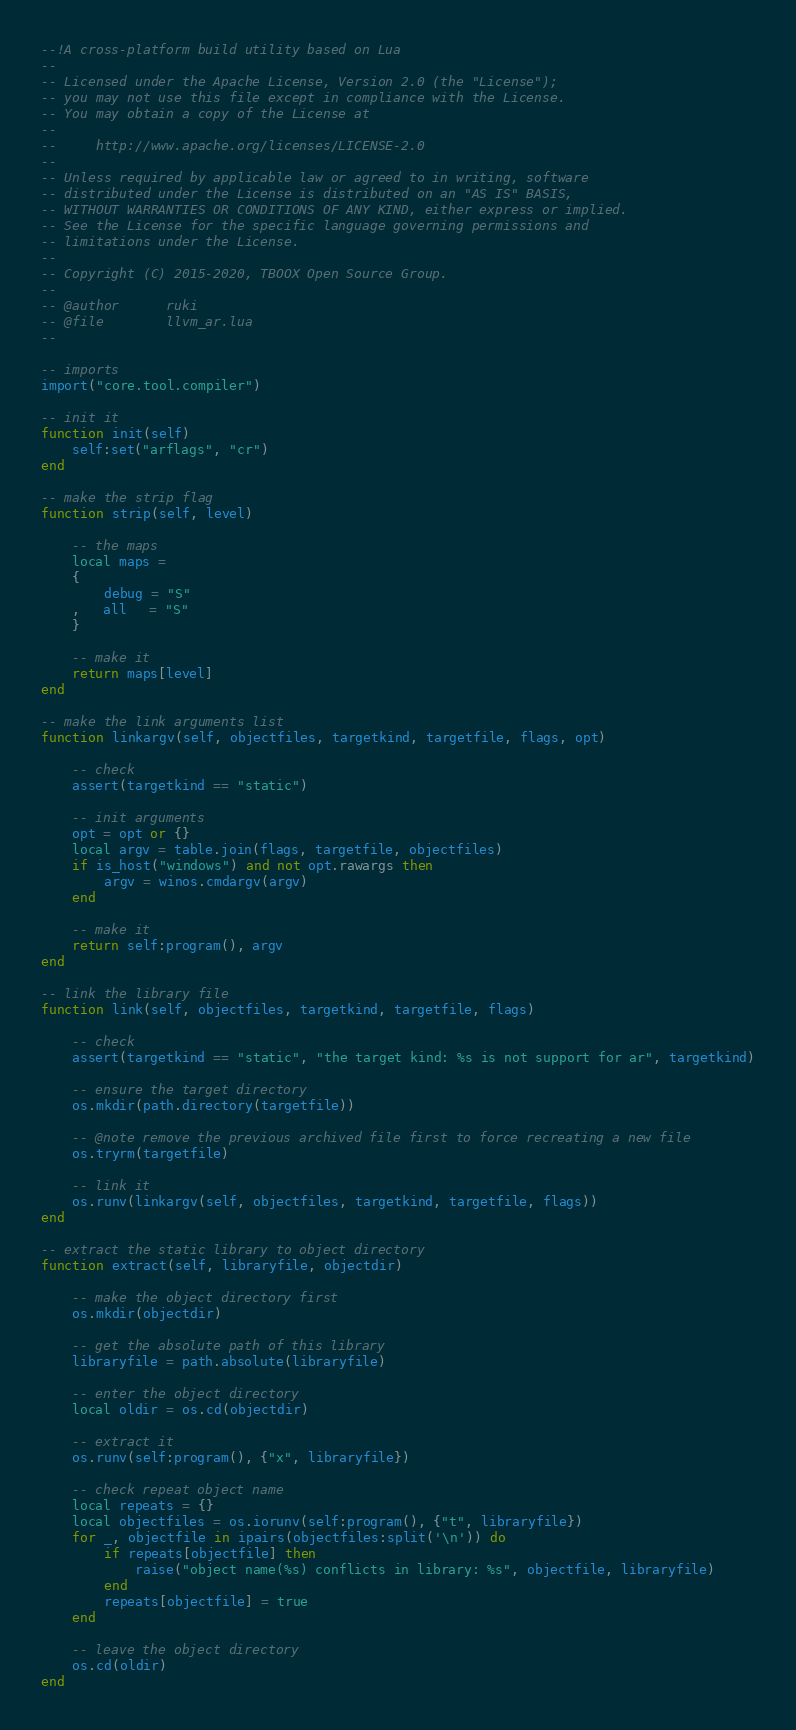Convert code to text. <code><loc_0><loc_0><loc_500><loc_500><_Lua_>--!A cross-platform build utility based on Lua
--
-- Licensed under the Apache License, Version 2.0 (the "License");
-- you may not use this file except in compliance with the License.
-- You may obtain a copy of the License at
--
--     http://www.apache.org/licenses/LICENSE-2.0
--
-- Unless required by applicable law or agreed to in writing, software
-- distributed under the License is distributed on an "AS IS" BASIS,
-- WITHOUT WARRANTIES OR CONDITIONS OF ANY KIND, either express or implied.
-- See the License for the specific language governing permissions and
-- limitations under the License.
-- 
-- Copyright (C) 2015-2020, TBOOX Open Source Group.
--
-- @author      ruki
-- @file        llvm_ar.lua
--

-- imports
import("core.tool.compiler")

-- init it
function init(self)
    self:set("arflags", "cr")
end

-- make the strip flag
function strip(self, level)

    -- the maps
    local maps = 
    {   
        debug = "S"
    ,   all   = "S"
    }

    -- make it
    return maps[level] 
end

-- make the link arguments list
function linkargv(self, objectfiles, targetkind, targetfile, flags, opt)

    -- check
    assert(targetkind == "static")

    -- init arguments
    opt = opt or {}
    local argv = table.join(flags, targetfile, objectfiles)
    if is_host("windows") and not opt.rawargs then
        argv = winos.cmdargv(argv)
    end

    -- make it
    return self:program(), argv
end

-- link the library file
function link(self, objectfiles, targetkind, targetfile, flags)

    -- check
    assert(targetkind == "static", "the target kind: %s is not support for ar", targetkind)

    -- ensure the target directory
    os.mkdir(path.directory(targetfile))

    -- @note remove the previous archived file first to force recreating a new file
    os.tryrm(targetfile)

    -- link it
    os.runv(linkargv(self, objectfiles, targetkind, targetfile, flags))
end

-- extract the static library to object directory
function extract(self, libraryfile, objectdir)

    -- make the object directory first
    os.mkdir(objectdir)

    -- get the absolute path of this library
    libraryfile = path.absolute(libraryfile)

    -- enter the object directory
    local oldir = os.cd(objectdir)

    -- extract it
    os.runv(self:program(), {"x", libraryfile})

    -- check repeat object name
    local repeats = {}
    local objectfiles = os.iorunv(self:program(), {"t", libraryfile})
    for _, objectfile in ipairs(objectfiles:split('\n')) do
        if repeats[objectfile] then
            raise("object name(%s) conflicts in library: %s", objectfile, libraryfile)
        end
        repeats[objectfile] = true
    end                                                          

    -- leave the object directory
    os.cd(oldir)
end

</code> 